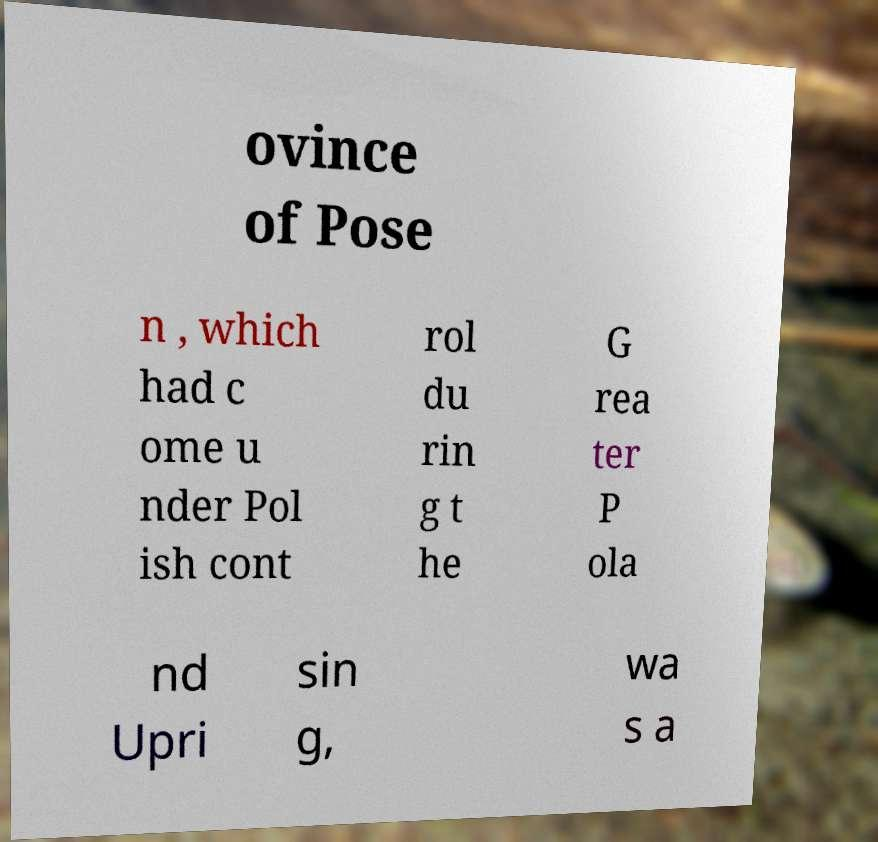I need the written content from this picture converted into text. Can you do that? ovince of Pose n , which had c ome u nder Pol ish cont rol du rin g t he G rea ter P ola nd Upri sin g, wa s a 